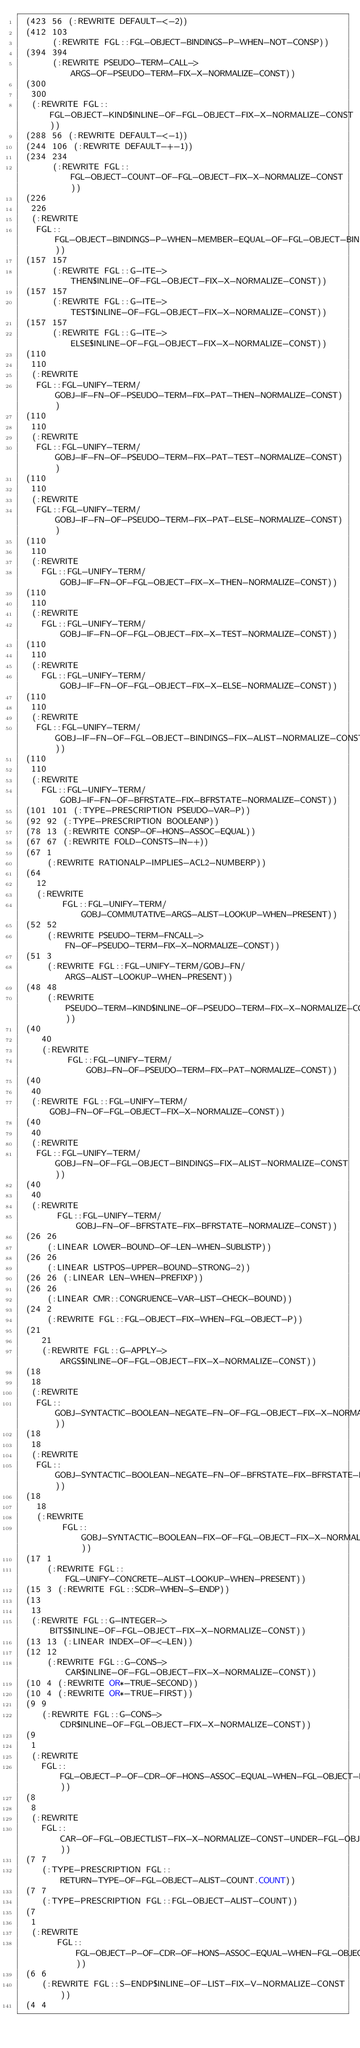Convert code to text. <code><loc_0><loc_0><loc_500><loc_500><_Lisp_> (423 56 (:REWRITE DEFAULT-<-2))
 (412 103
      (:REWRITE FGL::FGL-OBJECT-BINDINGS-P-WHEN-NOT-CONSP))
 (394 394
      (:REWRITE PSEUDO-TERM-CALL->ARGS-OF-PSEUDO-TERM-FIX-X-NORMALIZE-CONST))
 (300
  300
  (:REWRITE FGL::FGL-OBJECT-KIND$INLINE-OF-FGL-OBJECT-FIX-X-NORMALIZE-CONST))
 (288 56 (:REWRITE DEFAULT-<-1))
 (244 106 (:REWRITE DEFAULT-+-1))
 (234 234
      (:REWRITE FGL::FGL-OBJECT-COUNT-OF-FGL-OBJECT-FIX-X-NORMALIZE-CONST))
 (226
  226
  (:REWRITE
   FGL::FGL-OBJECT-BINDINGS-P-WHEN-MEMBER-EQUAL-OF-FGL-OBJECT-BINDINGSLIST-P))
 (157 157
      (:REWRITE FGL::G-ITE->THEN$INLINE-OF-FGL-OBJECT-FIX-X-NORMALIZE-CONST))
 (157 157
      (:REWRITE FGL::G-ITE->TEST$INLINE-OF-FGL-OBJECT-FIX-X-NORMALIZE-CONST))
 (157 157
      (:REWRITE FGL::G-ITE->ELSE$INLINE-OF-FGL-OBJECT-FIX-X-NORMALIZE-CONST))
 (110
  110
  (:REWRITE
   FGL::FGL-UNIFY-TERM/GOBJ-IF-FN-OF-PSEUDO-TERM-FIX-PAT-THEN-NORMALIZE-CONST))
 (110
  110
  (:REWRITE
   FGL::FGL-UNIFY-TERM/GOBJ-IF-FN-OF-PSEUDO-TERM-FIX-PAT-TEST-NORMALIZE-CONST))
 (110
  110
  (:REWRITE
   FGL::FGL-UNIFY-TERM/GOBJ-IF-FN-OF-PSEUDO-TERM-FIX-PAT-ELSE-NORMALIZE-CONST))
 (110
  110
  (:REWRITE
    FGL::FGL-UNIFY-TERM/GOBJ-IF-FN-OF-FGL-OBJECT-FIX-X-THEN-NORMALIZE-CONST))
 (110
  110
  (:REWRITE
    FGL::FGL-UNIFY-TERM/GOBJ-IF-FN-OF-FGL-OBJECT-FIX-X-TEST-NORMALIZE-CONST))
 (110
  110
  (:REWRITE
    FGL::FGL-UNIFY-TERM/GOBJ-IF-FN-OF-FGL-OBJECT-FIX-X-ELSE-NORMALIZE-CONST))
 (110
  110
  (:REWRITE
   FGL::FGL-UNIFY-TERM/GOBJ-IF-FN-OF-FGL-OBJECT-BINDINGS-FIX-ALIST-NORMALIZE-CONST))
 (110
  110
  (:REWRITE
    FGL::FGL-UNIFY-TERM/GOBJ-IF-FN-OF-BFRSTATE-FIX-BFRSTATE-NORMALIZE-CONST))
 (101 101 (:TYPE-PRESCRIPTION PSEUDO-VAR-P))
 (92 92 (:TYPE-PRESCRIPTION BOOLEANP))
 (78 13 (:REWRITE CONSP-OF-HONS-ASSOC-EQUAL))
 (67 67 (:REWRITE FOLD-CONSTS-IN-+))
 (67 1
     (:REWRITE RATIONALP-IMPLIES-ACL2-NUMBERP))
 (64
   12
   (:REWRITE
        FGL::FGL-UNIFY-TERM/GOBJ-COMMUTATIVE-ARGS-ALIST-LOOKUP-WHEN-PRESENT))
 (52 52
     (:REWRITE PSEUDO-TERM-FNCALL->FN-OF-PSEUDO-TERM-FIX-X-NORMALIZE-CONST))
 (51 3
     (:REWRITE FGL::FGL-UNIFY-TERM/GOBJ-FN/ARGS-ALIST-LOOKUP-WHEN-PRESENT))
 (48 48
     (:REWRITE PSEUDO-TERM-KIND$INLINE-OF-PSEUDO-TERM-FIX-X-NORMALIZE-CONST))
 (40
    40
    (:REWRITE
         FGL::FGL-UNIFY-TERM/GOBJ-FN-OF-PSEUDO-TERM-FIX-PAT-NORMALIZE-CONST))
 (40
  40
  (:REWRITE FGL::FGL-UNIFY-TERM/GOBJ-FN-OF-FGL-OBJECT-FIX-X-NORMALIZE-CONST))
 (40
  40
  (:REWRITE
   FGL::FGL-UNIFY-TERM/GOBJ-FN-OF-FGL-OBJECT-BINDINGS-FIX-ALIST-NORMALIZE-CONST))
 (40
  40
  (:REWRITE
       FGL::FGL-UNIFY-TERM/GOBJ-FN-OF-BFRSTATE-FIX-BFRSTATE-NORMALIZE-CONST))
 (26 26
     (:LINEAR LOWER-BOUND-OF-LEN-WHEN-SUBLISTP))
 (26 26
     (:LINEAR LISTPOS-UPPER-BOUND-STRONG-2))
 (26 26 (:LINEAR LEN-WHEN-PREFIXP))
 (26 26
     (:LINEAR CMR::CONGRUENCE-VAR-LIST-CHECK-BOUND))
 (24 2
     (:REWRITE FGL::FGL-OBJECT-FIX-WHEN-FGL-OBJECT-P))
 (21
    21
    (:REWRITE FGL::G-APPLY->ARGS$INLINE-OF-FGL-OBJECT-FIX-X-NORMALIZE-CONST))
 (18
  18
  (:REWRITE
   FGL::GOBJ-SYNTACTIC-BOOLEAN-NEGATE-FN-OF-FGL-OBJECT-FIX-X-NORMALIZE-CONST))
 (18
  18
  (:REWRITE
   FGL::GOBJ-SYNTACTIC-BOOLEAN-NEGATE-FN-OF-BFRSTATE-FIX-BFRSTATE-NORMALIZE-CONST))
 (18
   18
   (:REWRITE
        FGL::GOBJ-SYNTACTIC-BOOLEAN-FIX-OF-FGL-OBJECT-FIX-X-NORMALIZE-CONST))
 (17 1
     (:REWRITE FGL::FGL-UNIFY-CONCRETE-ALIST-LOOKUP-WHEN-PRESENT))
 (15 3 (:REWRITE FGL::SCDR-WHEN-S-ENDP))
 (13
  13
  (:REWRITE FGL::G-INTEGER->BITS$INLINE-OF-FGL-OBJECT-FIX-X-NORMALIZE-CONST))
 (13 13 (:LINEAR INDEX-OF-<-LEN))
 (12 12
     (:REWRITE FGL::G-CONS->CAR$INLINE-OF-FGL-OBJECT-FIX-X-NORMALIZE-CONST))
 (10 4 (:REWRITE OR*-TRUE-SECOND))
 (10 4 (:REWRITE OR*-TRUE-FIRST))
 (9 9
    (:REWRITE FGL::G-CONS->CDR$INLINE-OF-FGL-OBJECT-FIX-X-NORMALIZE-CONST))
 (9
  1
  (:REWRITE
    FGL::FGL-OBJECT-P-OF-CDR-OF-HONS-ASSOC-EQUAL-WHEN-FGL-OBJECT-BINDINGS-P))
 (8
  8
  (:REWRITE
    FGL::CAR-OF-FGL-OBJECTLIST-FIX-X-NORMALIZE-CONST-UNDER-FGL-OBJECT-EQUIV))
 (7 7
    (:TYPE-PRESCRIPTION FGL::RETURN-TYPE-OF-FGL-OBJECT-ALIST-COUNT.COUNT))
 (7 7
    (:TYPE-PRESCRIPTION FGL::FGL-OBJECT-ALIST-COUNT))
 (7
  1
  (:REWRITE
       FGL::FGL-OBJECT-P-OF-CDR-OF-HONS-ASSOC-EQUAL-WHEN-FGL-OBJECT-ALIST-P))
 (6 6
    (:REWRITE FGL::S-ENDP$INLINE-OF-LIST-FIX-V-NORMALIZE-CONST))
 (4 4</code> 